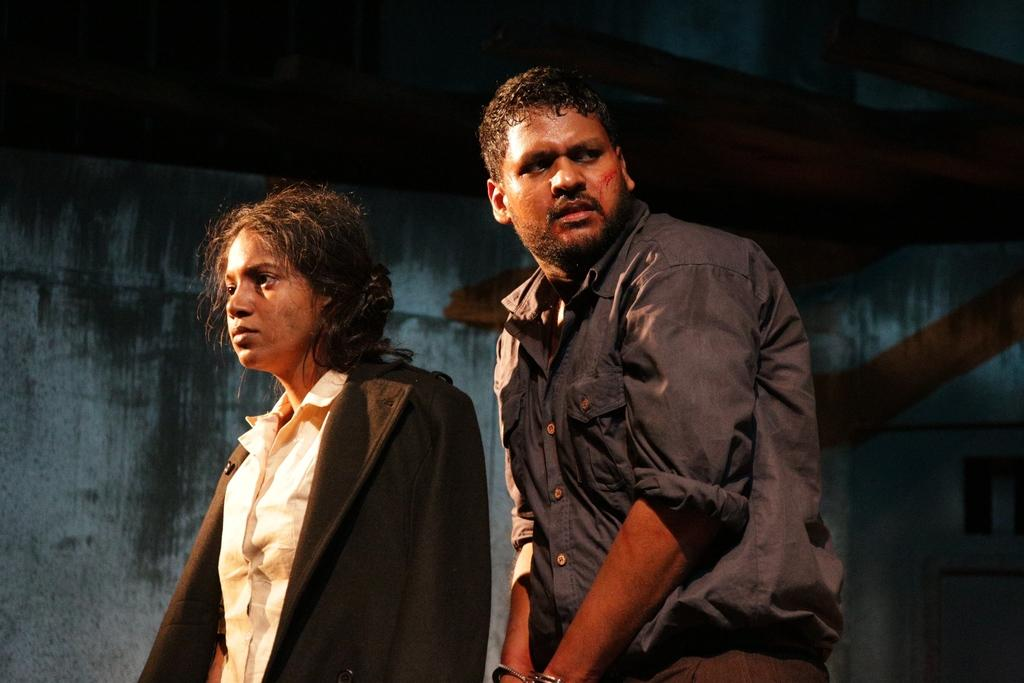Who is on the left side of the image? There is a woman on the left side of the image. What is the woman wearing? The woman is wearing a black coat. Who is beside the woman? There is a man beside the woman. What is the man wearing? The man is wearing a shirt. What type of rock can be seen in the office where the woman and man are standing? There is no rock or office present in the image; it features a woman and a man standing next to each other. Are the woman and man in the image brothers? There is no information provided about their relationship, so it cannot be determined if they are brothers. 